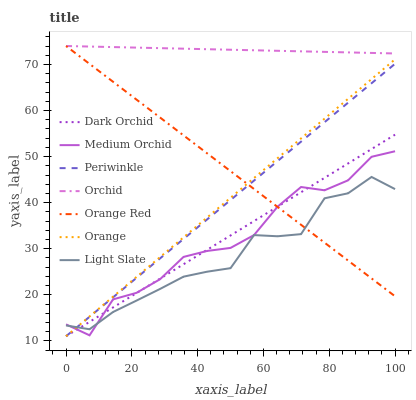Does Light Slate have the minimum area under the curve?
Answer yes or no. Yes. Does Orchid have the maximum area under the curve?
Answer yes or no. Yes. Does Medium Orchid have the minimum area under the curve?
Answer yes or no. No. Does Medium Orchid have the maximum area under the curve?
Answer yes or no. No. Is Orchid the smoothest?
Answer yes or no. Yes. Is Medium Orchid the roughest?
Answer yes or no. Yes. Is Dark Orchid the smoothest?
Answer yes or no. No. Is Dark Orchid the roughest?
Answer yes or no. No. Does Dark Orchid have the lowest value?
Answer yes or no. Yes. Does Medium Orchid have the lowest value?
Answer yes or no. No. Does Orchid have the highest value?
Answer yes or no. Yes. Does Medium Orchid have the highest value?
Answer yes or no. No. Is Dark Orchid less than Orchid?
Answer yes or no. Yes. Is Orchid greater than Dark Orchid?
Answer yes or no. Yes. Does Periwinkle intersect Light Slate?
Answer yes or no. Yes. Is Periwinkle less than Light Slate?
Answer yes or no. No. Is Periwinkle greater than Light Slate?
Answer yes or no. No. Does Dark Orchid intersect Orchid?
Answer yes or no. No. 